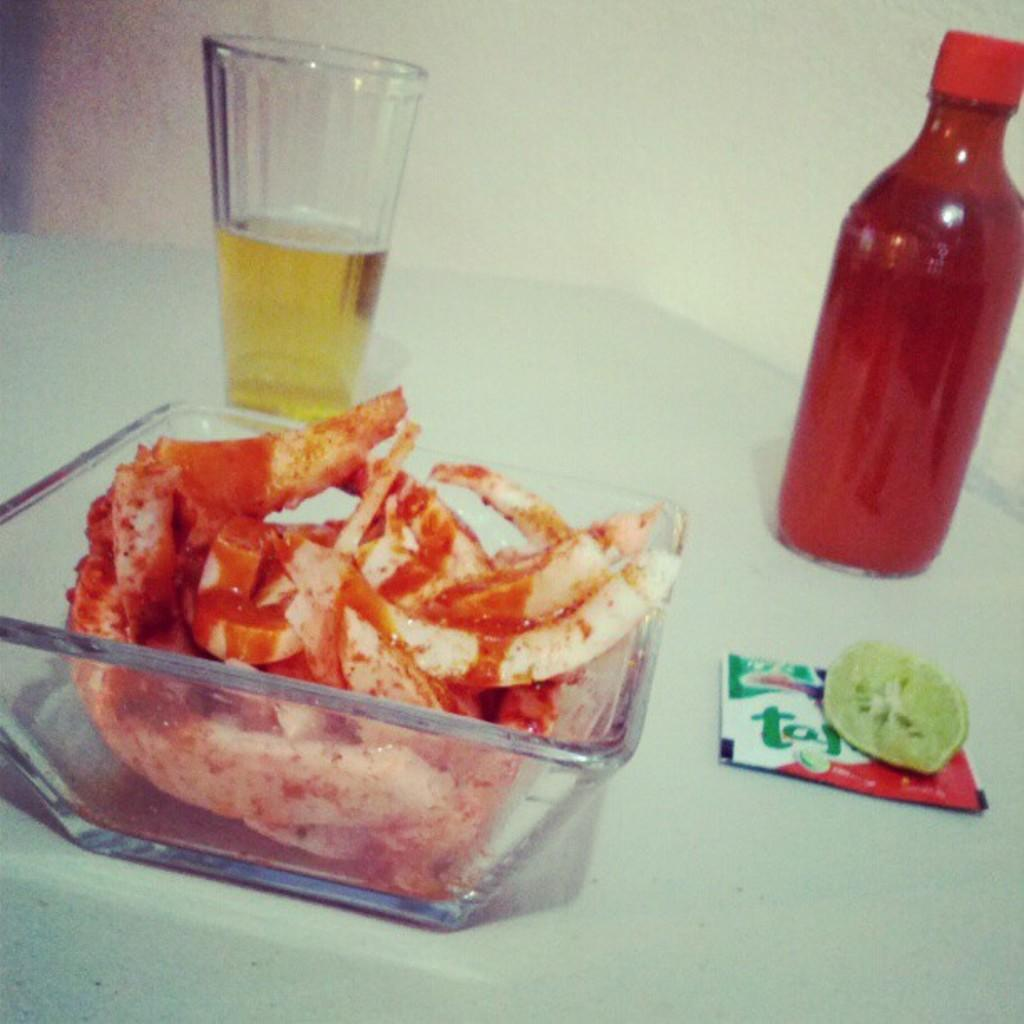What type of container is visible in the image? There is a glass in the image. What other type of container is present in the image? There is a water bottle in the image. What is placed inside the glass? There is a lemon slice in the glass. What might be used for holding food in the image? There is a food bowl in the image. Can you tell me the route the cat takes to reach the water bottle in the image? There is no cat present in the image, so it is not possible to determine a route. 